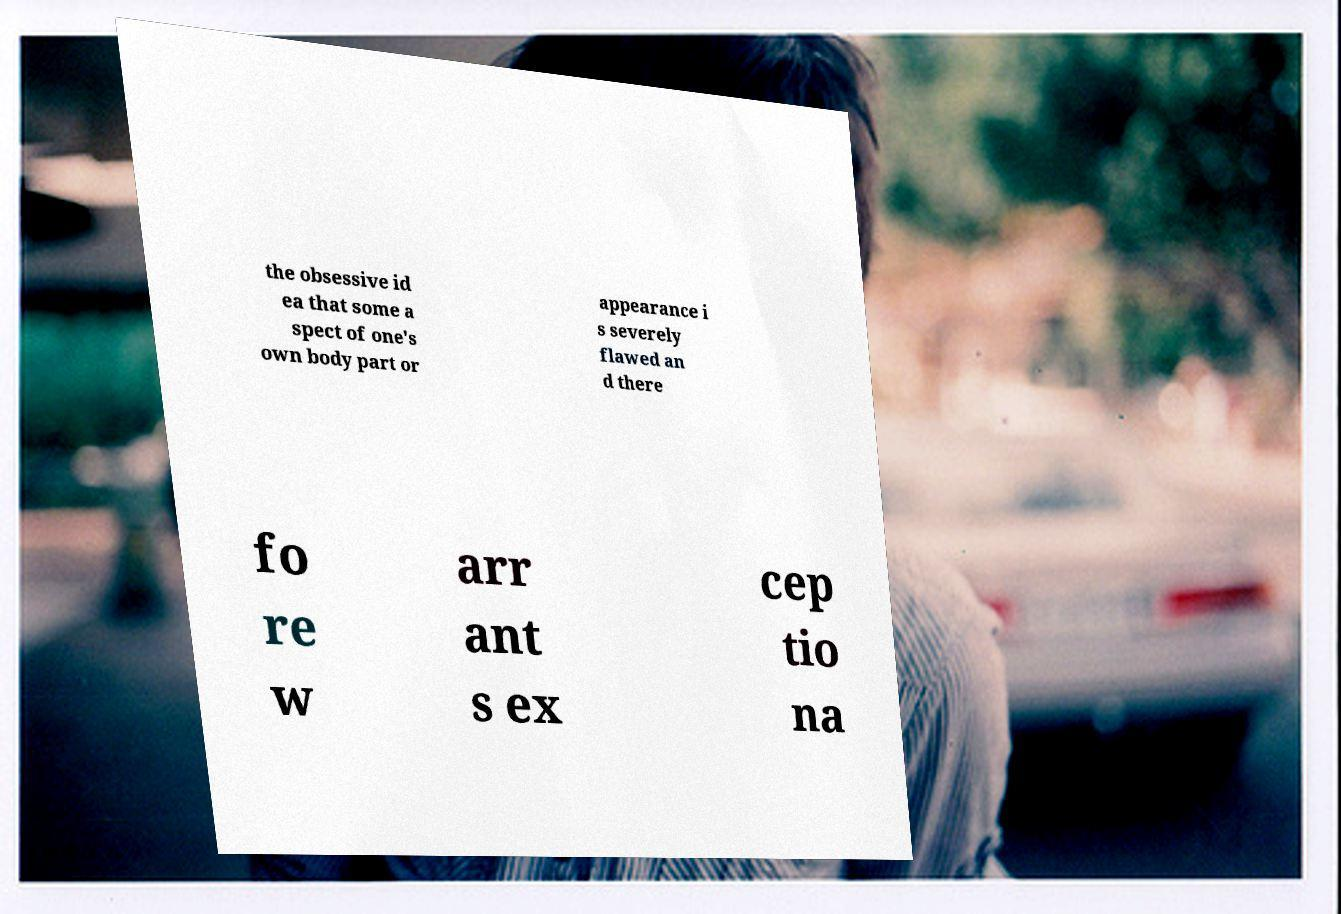Can you read and provide the text displayed in the image?This photo seems to have some interesting text. Can you extract and type it out for me? the obsessive id ea that some a spect of one's own body part or appearance i s severely flawed an d there fo re w arr ant s ex cep tio na 